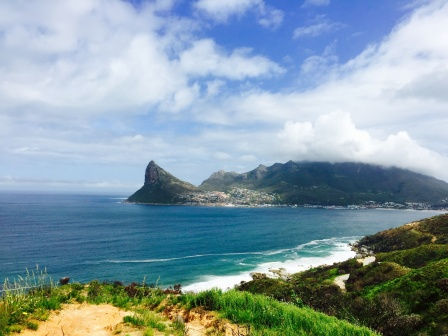What cultural significance might this place hold for the local inhabitants? The coastal town and its surrounding landscape likely hold deep cultural significance for the local inhabitants. The ocean could be revered as a source of life and sustenance, with fishing being a traditional livelihood passed down through generations. Local festivals might celebrate the bounty of the sea, with vibrant parades, traditional music, and culinary feasts featuring fresh seafood and local delicacies.

The green hills and rocky coastline could be steeped in legend and folklore, with tales of ancient guardians, mythical creatures, and historical events that shaped the community's identity. These stories might be told through oral traditions, art, and community gatherings, fostering a strong sense of heritage and pride among the residents.

The town itself could be a close-knit community where people share a deep connection to their environment and each other. Traditions such as communal fishing expeditions, harvest festivals, and seasonal celebrations might play a significant role in maintaining social bonds and preserving cultural heritage.

Overall, the place depicted in the image would be more than just a beautiful setting; it would be a living tapestry of history, culture, and community, deeply cherished by those who call it home. 